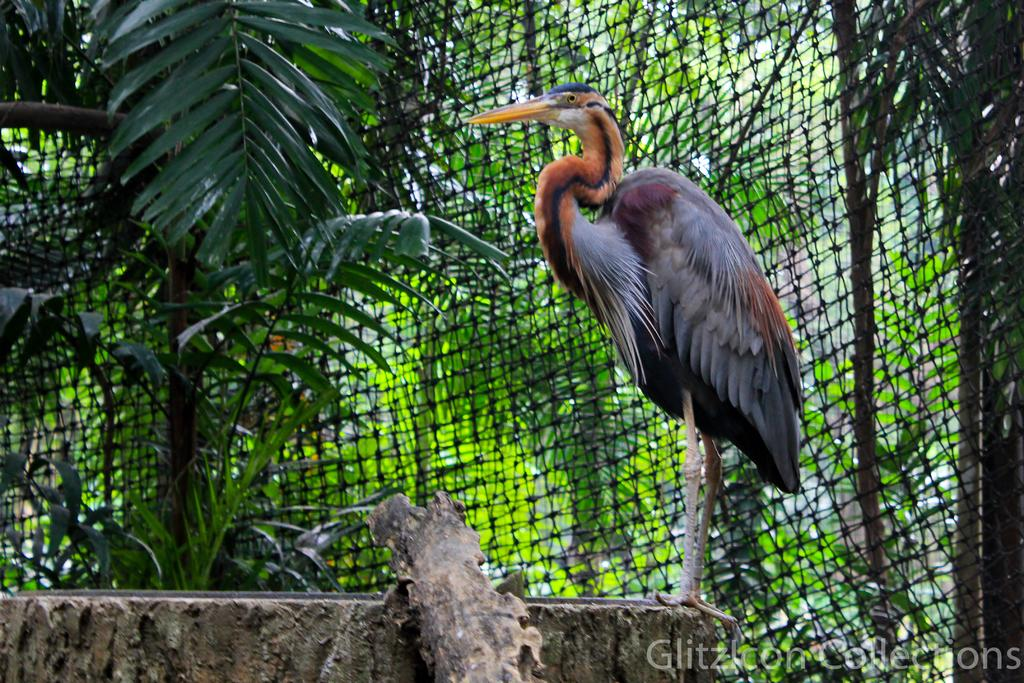What type of animal can be seen in the image? There is a bird in the image. Where is the bird located in the image? The bird is standing on a path in the image. What other objects or structures are visible in the image? There is a fence and trees in the image. Is there any indication of the image's origin or ownership? Yes, there is a watermark on the image. How many pizzas are being delivered by the bird in the image? There are no pizzas present in the image, and the bird is not delivering anything. 